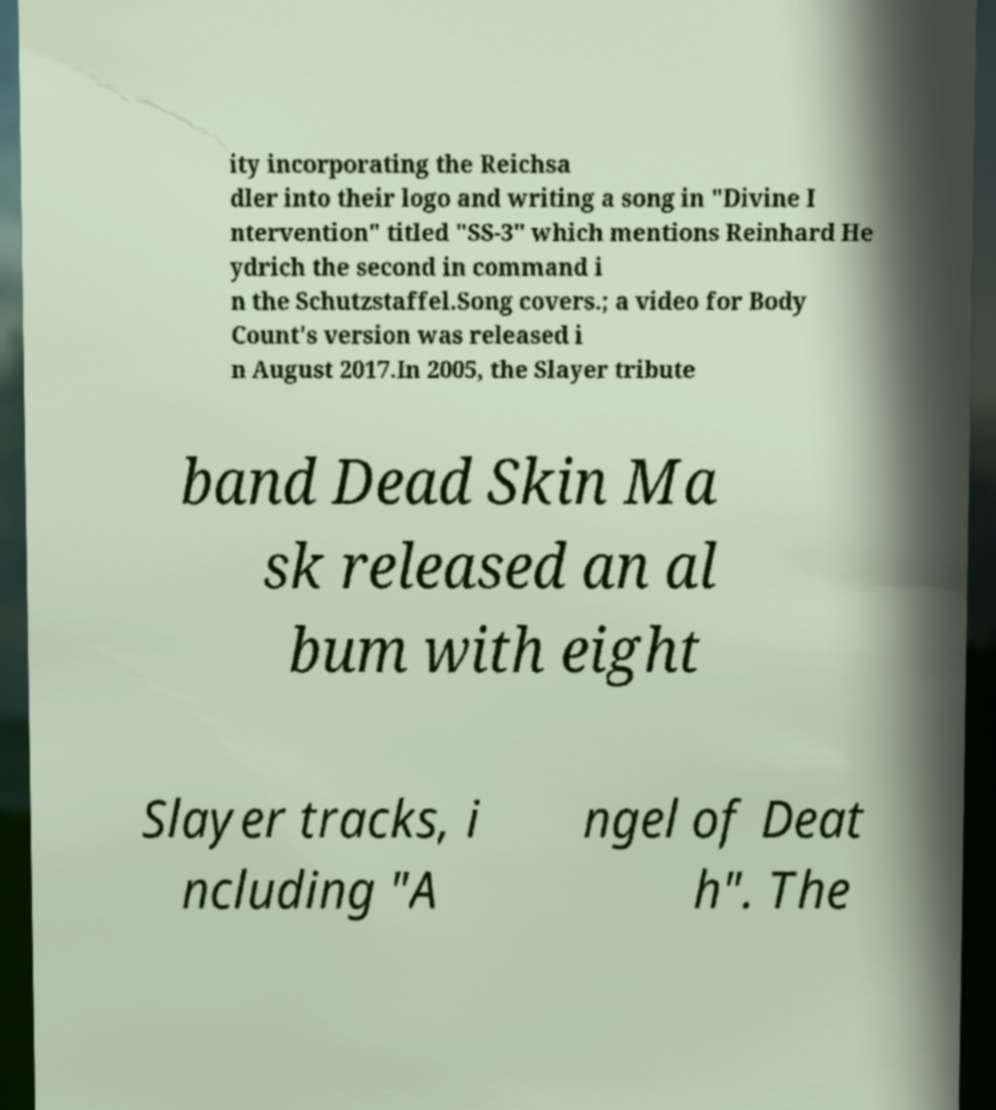I need the written content from this picture converted into text. Can you do that? ity incorporating the Reichsa dler into their logo and writing a song in "Divine I ntervention" titled "SS-3" which mentions Reinhard He ydrich the second in command i n the Schutzstaffel.Song covers.; a video for Body Count's version was released i n August 2017.In 2005, the Slayer tribute band Dead Skin Ma sk released an al bum with eight Slayer tracks, i ncluding "A ngel of Deat h". The 